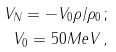Convert formula to latex. <formula><loc_0><loc_0><loc_500><loc_500>V _ { N } = - V _ { 0 } \rho / \rho _ { 0 } \, ; \\ \ V _ { 0 } = 5 0 M e V \, ,</formula> 